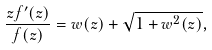Convert formula to latex. <formula><loc_0><loc_0><loc_500><loc_500>\frac { z f ^ { \prime } ( z ) } { f ( z ) } = w ( z ) + \sqrt { 1 + w ^ { 2 } ( z ) } ,</formula> 